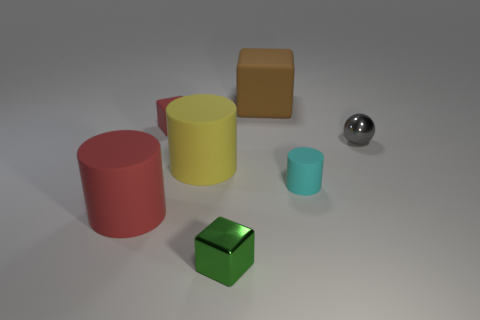Can you describe the colors and shapes visible in this scene? Certainly! In the scene, there are objects of various shapes including cylinders, cubes, and a sphere. The colors of these objects range from red, yellow, and teal to brown and silver. Which object stands out the most to you and why? The silver sphere stands out due to its reflective surface, which contrasts with the matte textures of the other objects. Its spherical shape also differs from the other geometric figures, catching the eye. 